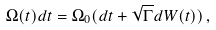<formula> <loc_0><loc_0><loc_500><loc_500>\Omega ( t ) d t = \Omega _ { 0 } ( d t + \sqrt { \Gamma } d W ( t ) ) \, ,</formula> 